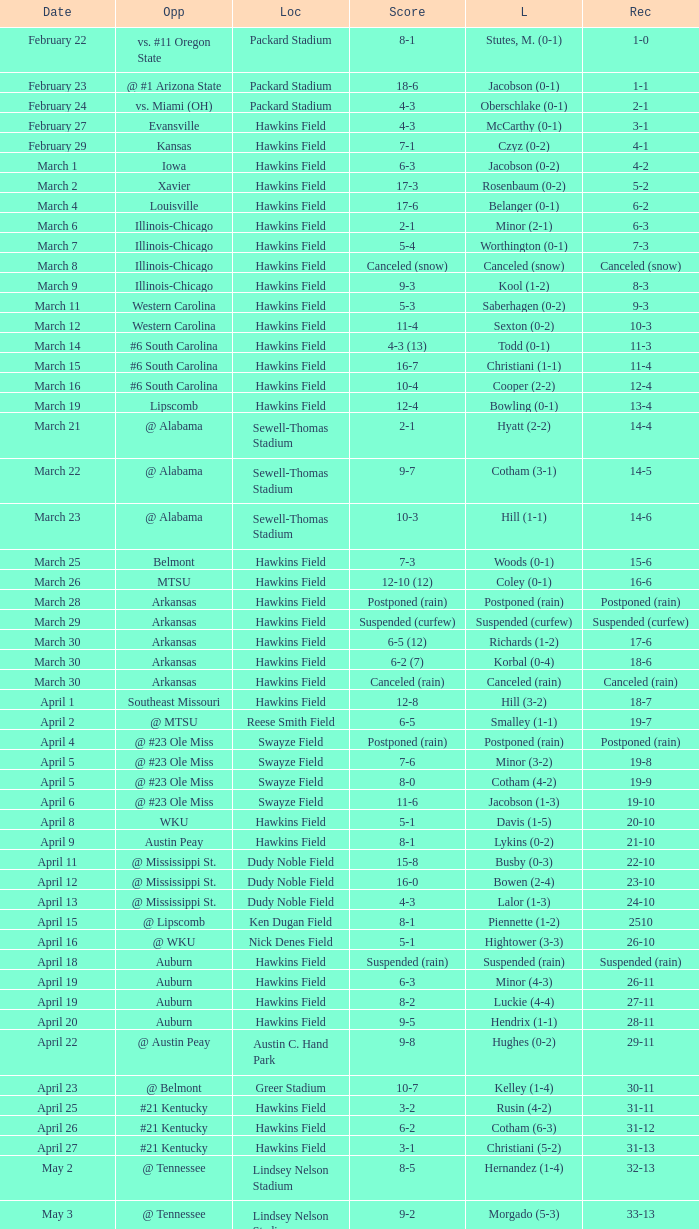What was the location of the game when the record was 2-1? Packard Stadium. 